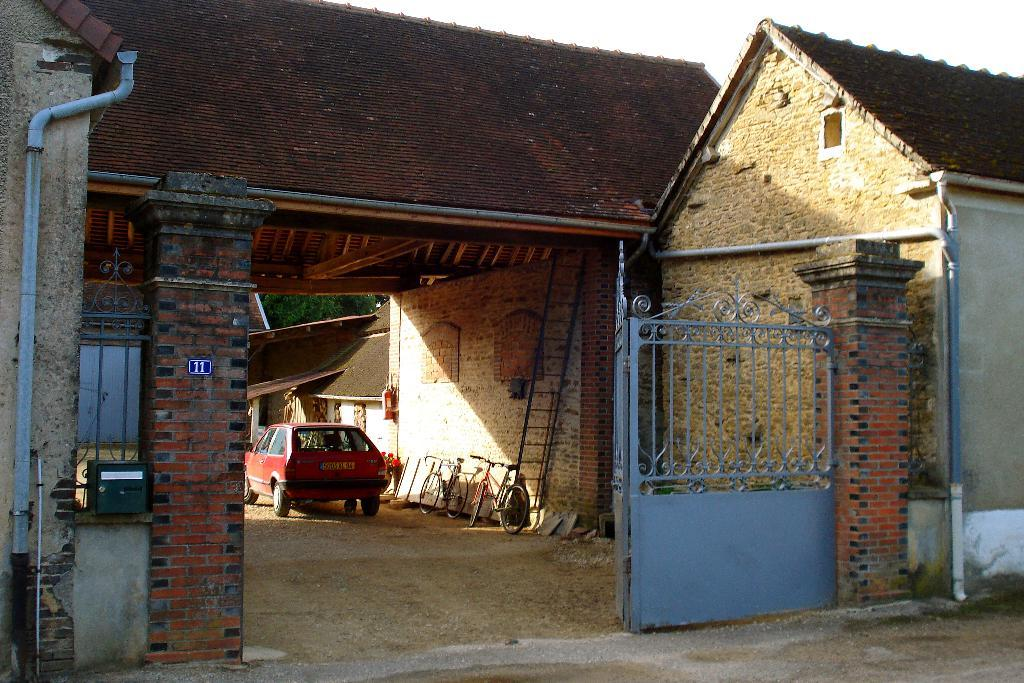What type of houses can be seen in the image? There are brick houses in the image. What other objects can be seen in the image? There are pipes, a blue gate, a ladder, bicycles, a red car, and trees in the image. Can you describe the gate in the image? The gate in the image is blue. What is the color of the car in the image? The car in the image is red. What type of vegetation is present in the image? There are trees in the image. Where is the pear located in the image? There is no pear present in the image. What type of food is being served in the lunchroom in the image? There is no lunchroom present in the image. 